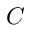Convert formula to latex. <formula><loc_0><loc_0><loc_500><loc_500>C</formula> 